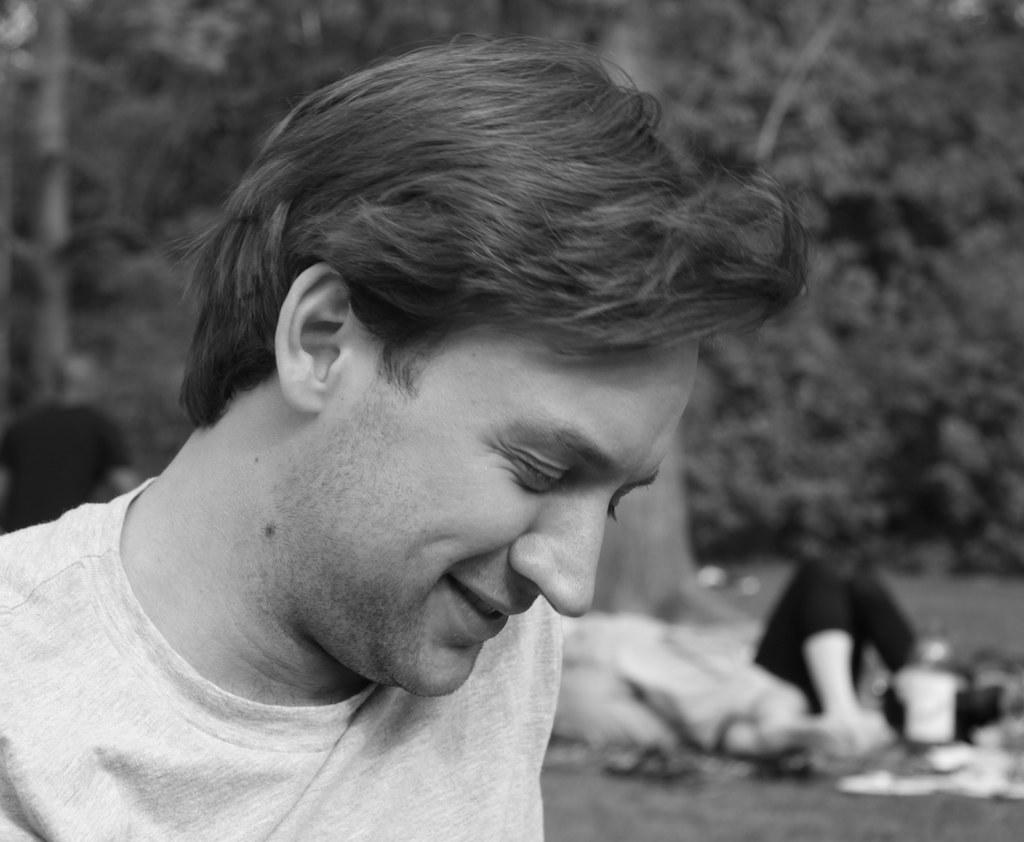What type of picture is in the image? The image contains a black and white picture of a person. What is the person wearing in the picture? The person is wearing a t-shirt. What can be seen in the background of the picture? There are trees and blurry objects in the background of the image. What type of silver is being used to stimulate the person's nerves in the image? There is no silver or mention of nerves in the image; it features a black and white picture of a person wearing a t-shirt with trees and blurry objects in the background. 